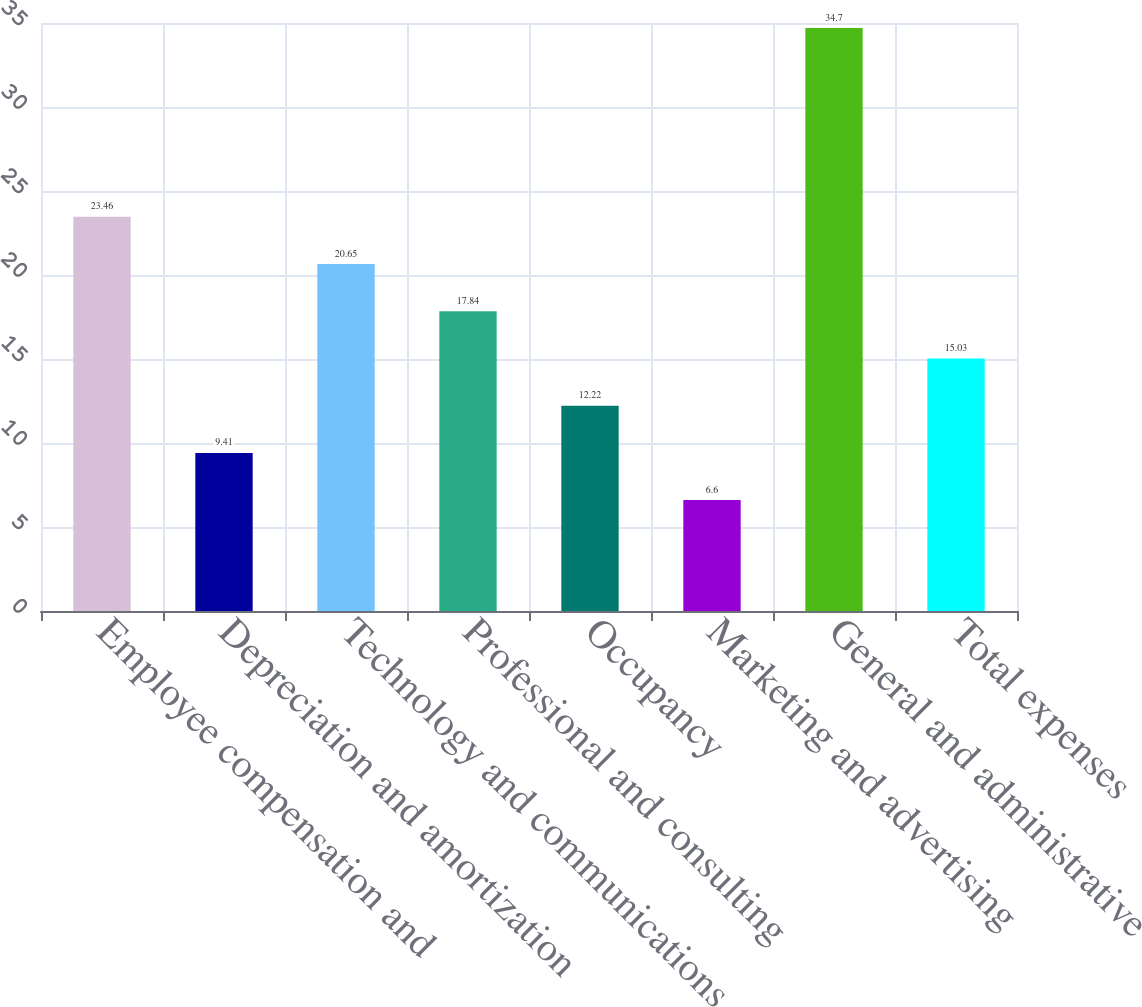Convert chart. <chart><loc_0><loc_0><loc_500><loc_500><bar_chart><fcel>Employee compensation and<fcel>Depreciation and amortization<fcel>Technology and communications<fcel>Professional and consulting<fcel>Occupancy<fcel>Marketing and advertising<fcel>General and administrative<fcel>Total expenses<nl><fcel>23.46<fcel>9.41<fcel>20.65<fcel>17.84<fcel>12.22<fcel>6.6<fcel>34.7<fcel>15.03<nl></chart> 